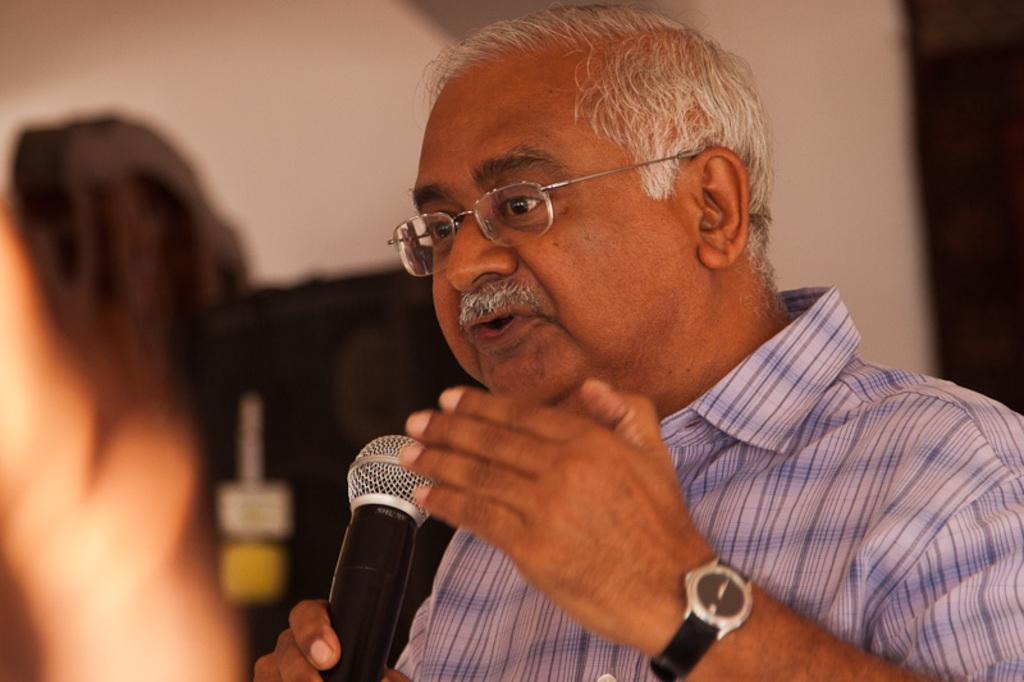What is the main subject of the image? There is a person in the image. What is the person holding in the image? The person is holding a mic. Where is the person located in the image? The person is in the center of the image. How many goldfish are swimming in the background of the image? There are no goldfish present in the image. What type of slip is the person wearing in the image? The image does not show the person's footwear, so it cannot be determined if they are wearing a slip or any other type of footwear. 